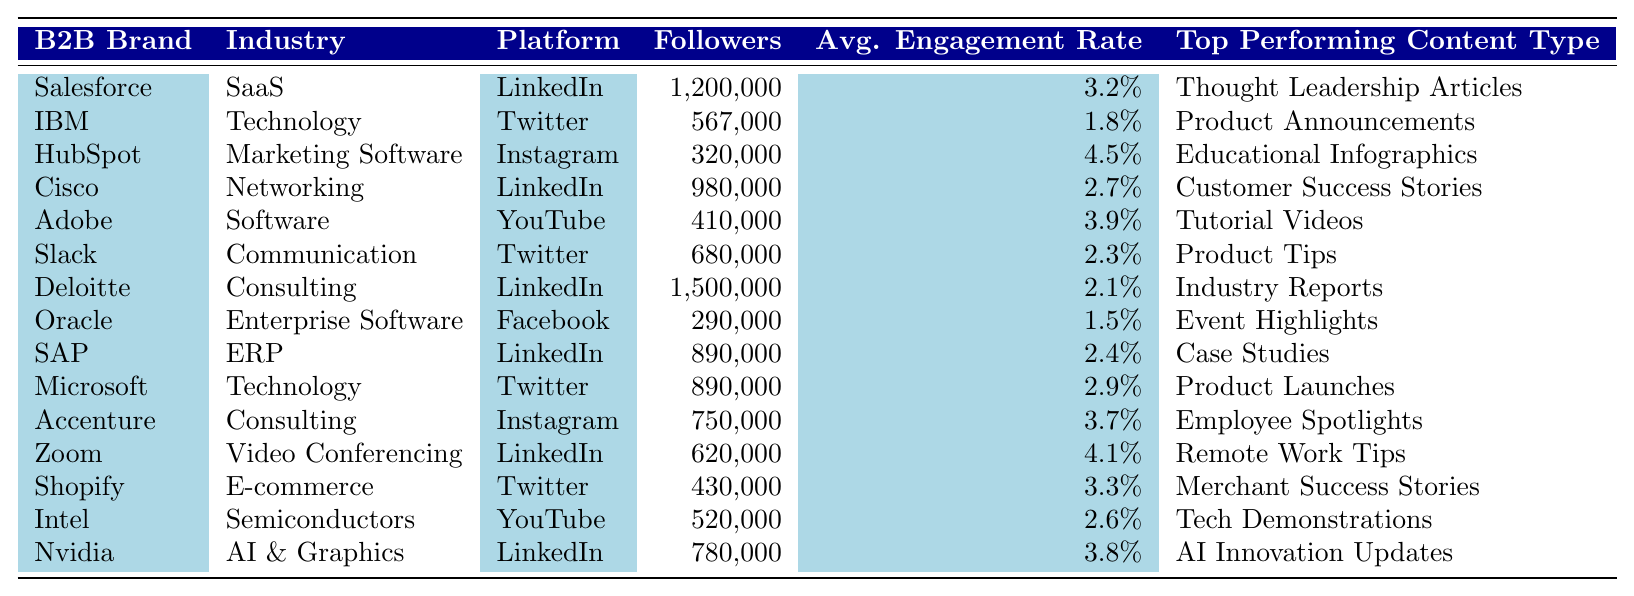What is the average engagement rate for all brands listed? To find the average engagement rate, we add up all the engagement rates: 3.2 + 1.8 + 4.5 + 2.7 + 3.9 + 2.3 + 2.1 + 1.5 + 2.4 + 2.9 + 3.7 + 4.1 + 3.3 + 2.6 + 3.8 = 33.0%. There are 15 brands, so we divide the total by 15: 33.0% / 15 = 2.2%.
Answer: 2.2% Which brand has the highest number of followers? By reviewing the "Followers" column, we see that Deloitte has 1,500,000 followers, which is the highest compared to all other brands listed.
Answer: Deloitte Is there a brand in the Networking industry with an engagement rate above 2.5%? Cisco is the only brand listed under Networking, and it has an engagement rate of 2.7%, which is above 2.5%. Therefore, the answer is yes.
Answer: Yes What is the engagement rate difference between HubSpot and Adobe? HubSpot has an engagement rate of 4.5% and Adobe has 3.9%. To find the difference, we subtract Adobe's engagement rate from HubSpot's: 4.5% - 3.9% = 0.6%.
Answer: 0.6% Which platform has the highest average engagement rate among the listed brands? First, we categorize and sum the engagement rates by platform. LinkedIn has 3.2% (Salesforce), 2.7% (Cisco), 2.1% (Deloitte), 2.4% (SAP), and 3.8% (Nvidia) which totals to 15.2%. There are 5 LinkedIn entries, averaging 3.04%. Instagram has 4.5% (HubSpot) and 3.7% (Accenture), totaling 8.2% for an average of 4.1%. The other platforms (Twitter, YouTube, Facebook) have lower average rates, concluding that Instagram has the highest average engagement rate.
Answer: Instagram Which B2B brand uses Thought Leadership Articles as their top performing content type? Looking through the "Top Performing Content Type" column, Salesforce is the brand associated with Thought Leadership Articles.
Answer: Salesforce Are there more brands on LinkedIn or Twitter? Counting the entries, we find 5 brands listed for LinkedIn (Salesforce, Cisco, Deloitte, SAP, Nvidia) and 4 for Twitter (IBM, Slack, Microsoft, Shopify). Therefore, LinkedIn has more brands than Twitter.
Answer: LinkedIn What percentage of the total followers are from brands with an average engagement rate greater than 3%? We identify the brands with engagement rates over 3%: Salesforce (1,200,000), HubSpot (320,000), Adobe (410,000), Accenture (750,000), Zoom (620,000), and Nvidia (780,000). Their total followers sum to 3,080,000. Meanwhile, the total number of followers from all brands is 9,750,000. The percentage is then calculated as (3,080,000 / 9,750,000) * 100 ≈ 31.6%.
Answer: 31.6% Which B2B brand has the lowest engagement rate and what type of content do they produce? Scanning the engagement rates, Oracle has the lowest rate at 1.5%. Their top performing content type is Event Highlights.
Answer: Oracle, Event Highlights 